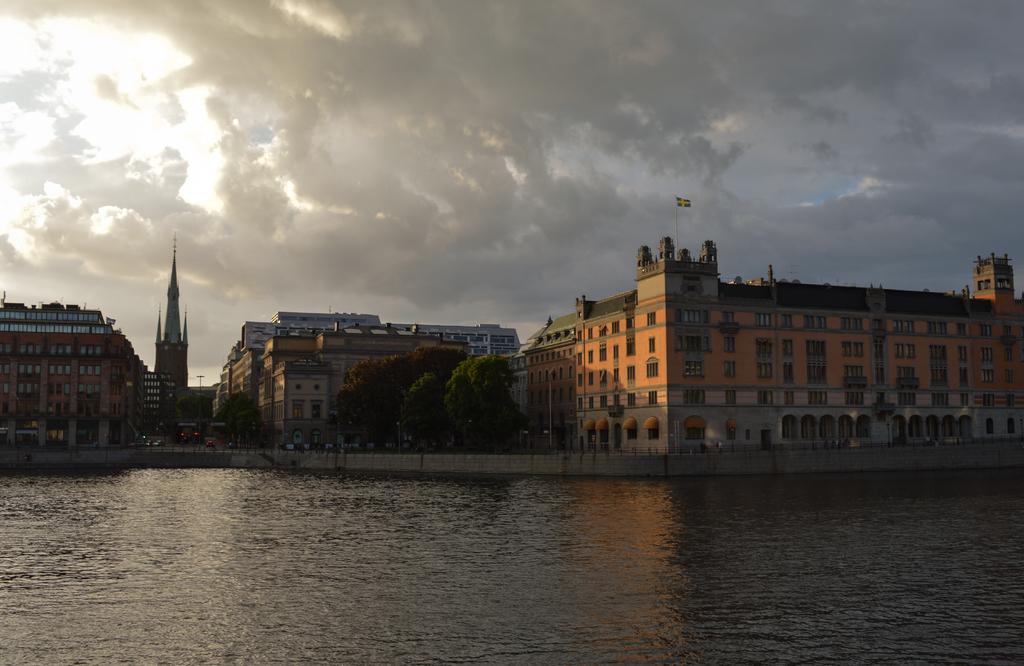Can you describe this image briefly? This picture is taken from outside of the city. In this image, we can see some trees, buildings, towers, flags. At the top, we can see water in a lake, at the bottom, we can see water in a lake. 